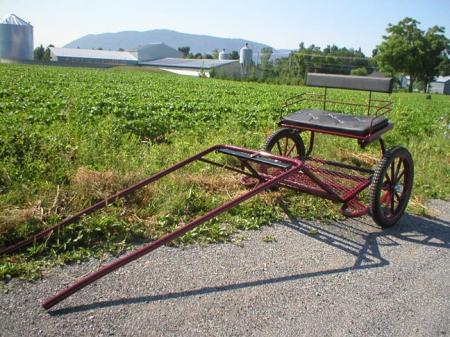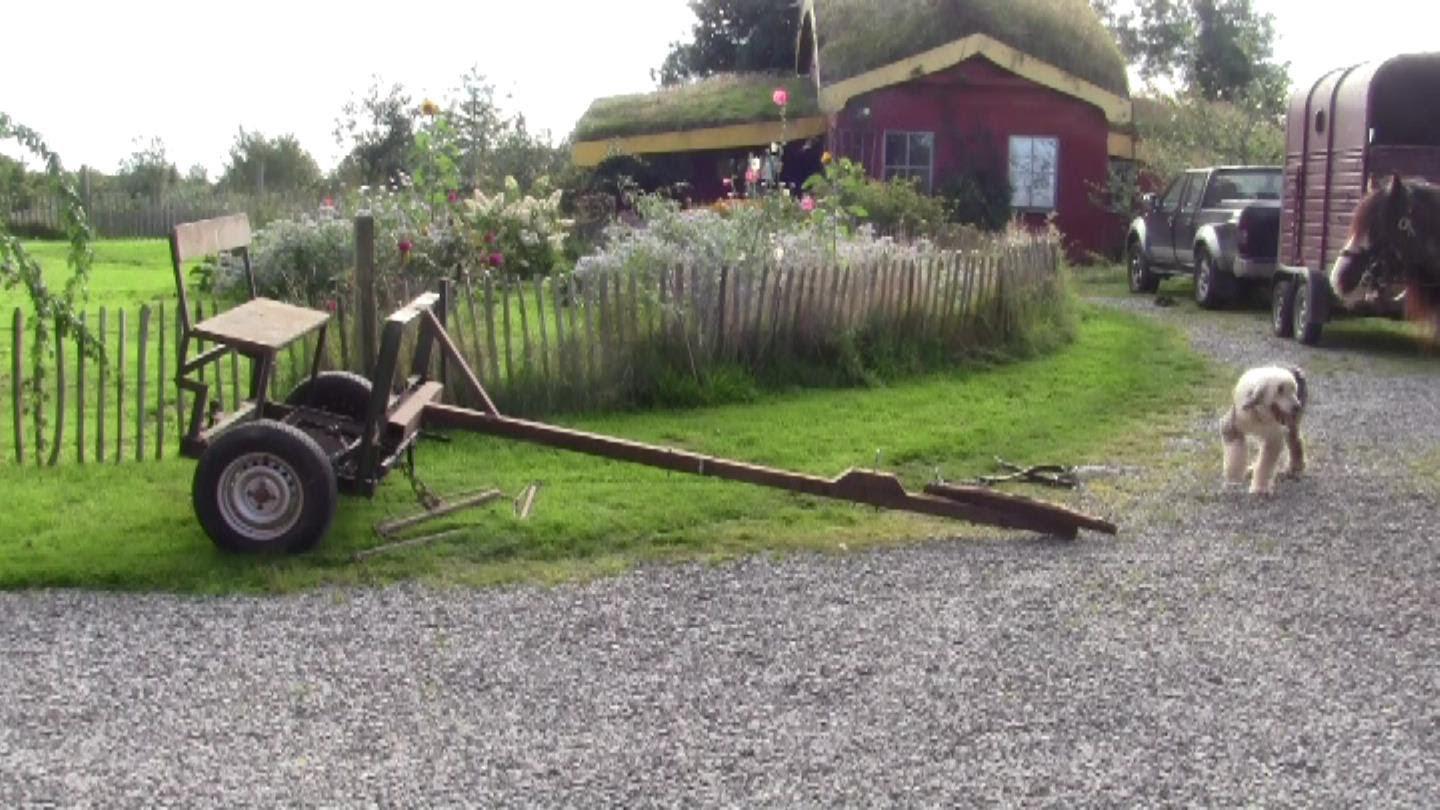The first image is the image on the left, the second image is the image on the right. Evaluate the accuracy of this statement regarding the images: "There is exactly one horse in the iamge on the left.". Is it true? Answer yes or no. No. 